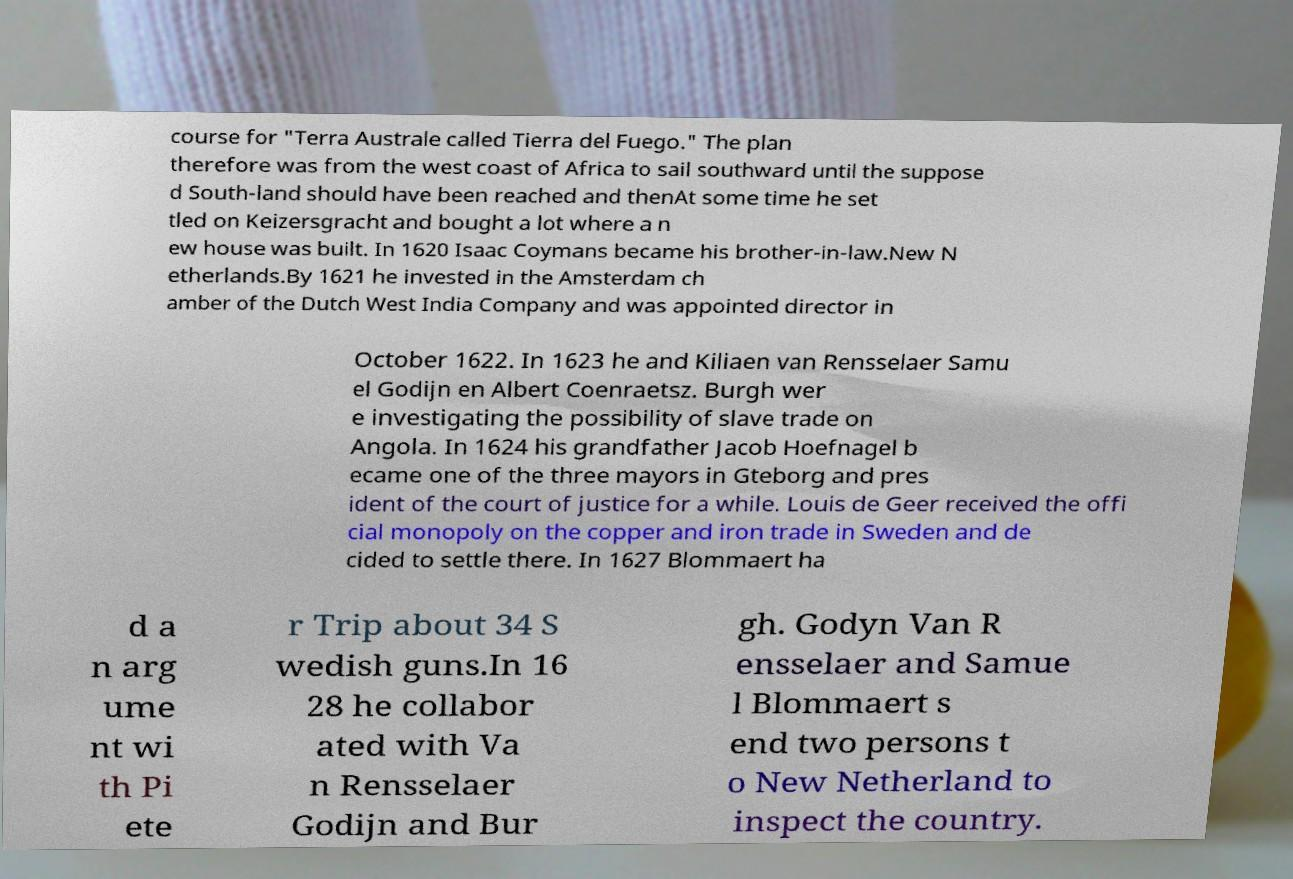Could you assist in decoding the text presented in this image and type it out clearly? course for "Terra Australe called Tierra del Fuego." The plan therefore was from the west coast of Africa to sail southward until the suppose d South-land should have been reached and thenAt some time he set tled on Keizersgracht and bought a lot where a n ew house was built. In 1620 Isaac Coymans became his brother-in-law.New N etherlands.By 1621 he invested in the Amsterdam ch amber of the Dutch West India Company and was appointed director in October 1622. In 1623 he and Kiliaen van Rensselaer Samu el Godijn en Albert Coenraetsz. Burgh wer e investigating the possibility of slave trade on Angola. In 1624 his grandfather Jacob Hoefnagel b ecame one of the three mayors in Gteborg and pres ident of the court of justice for a while. Louis de Geer received the offi cial monopoly on the copper and iron trade in Sweden and de cided to settle there. In 1627 Blommaert ha d a n arg ume nt wi th Pi ete r Trip about 34 S wedish guns.In 16 28 he collabor ated with Va n Rensselaer Godijn and Bur gh. Godyn Van R ensselaer and Samue l Blommaert s end two persons t o New Netherland to inspect the country. 